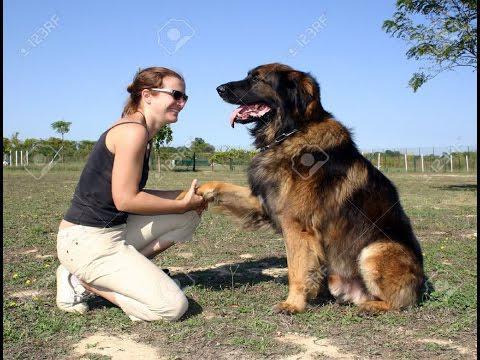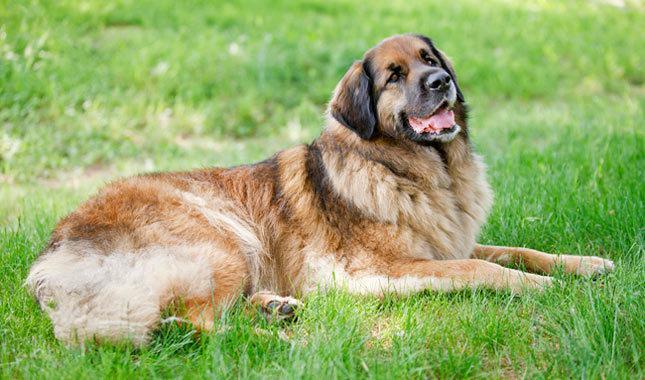The first image is the image on the left, the second image is the image on the right. Analyze the images presented: Is the assertion "Right image contains more dogs than the left image." valid? Answer yes or no. No. The first image is the image on the left, the second image is the image on the right. For the images displayed, is the sentence "One dog is sitting in the short grass in the image on the left." factually correct? Answer yes or no. Yes. 